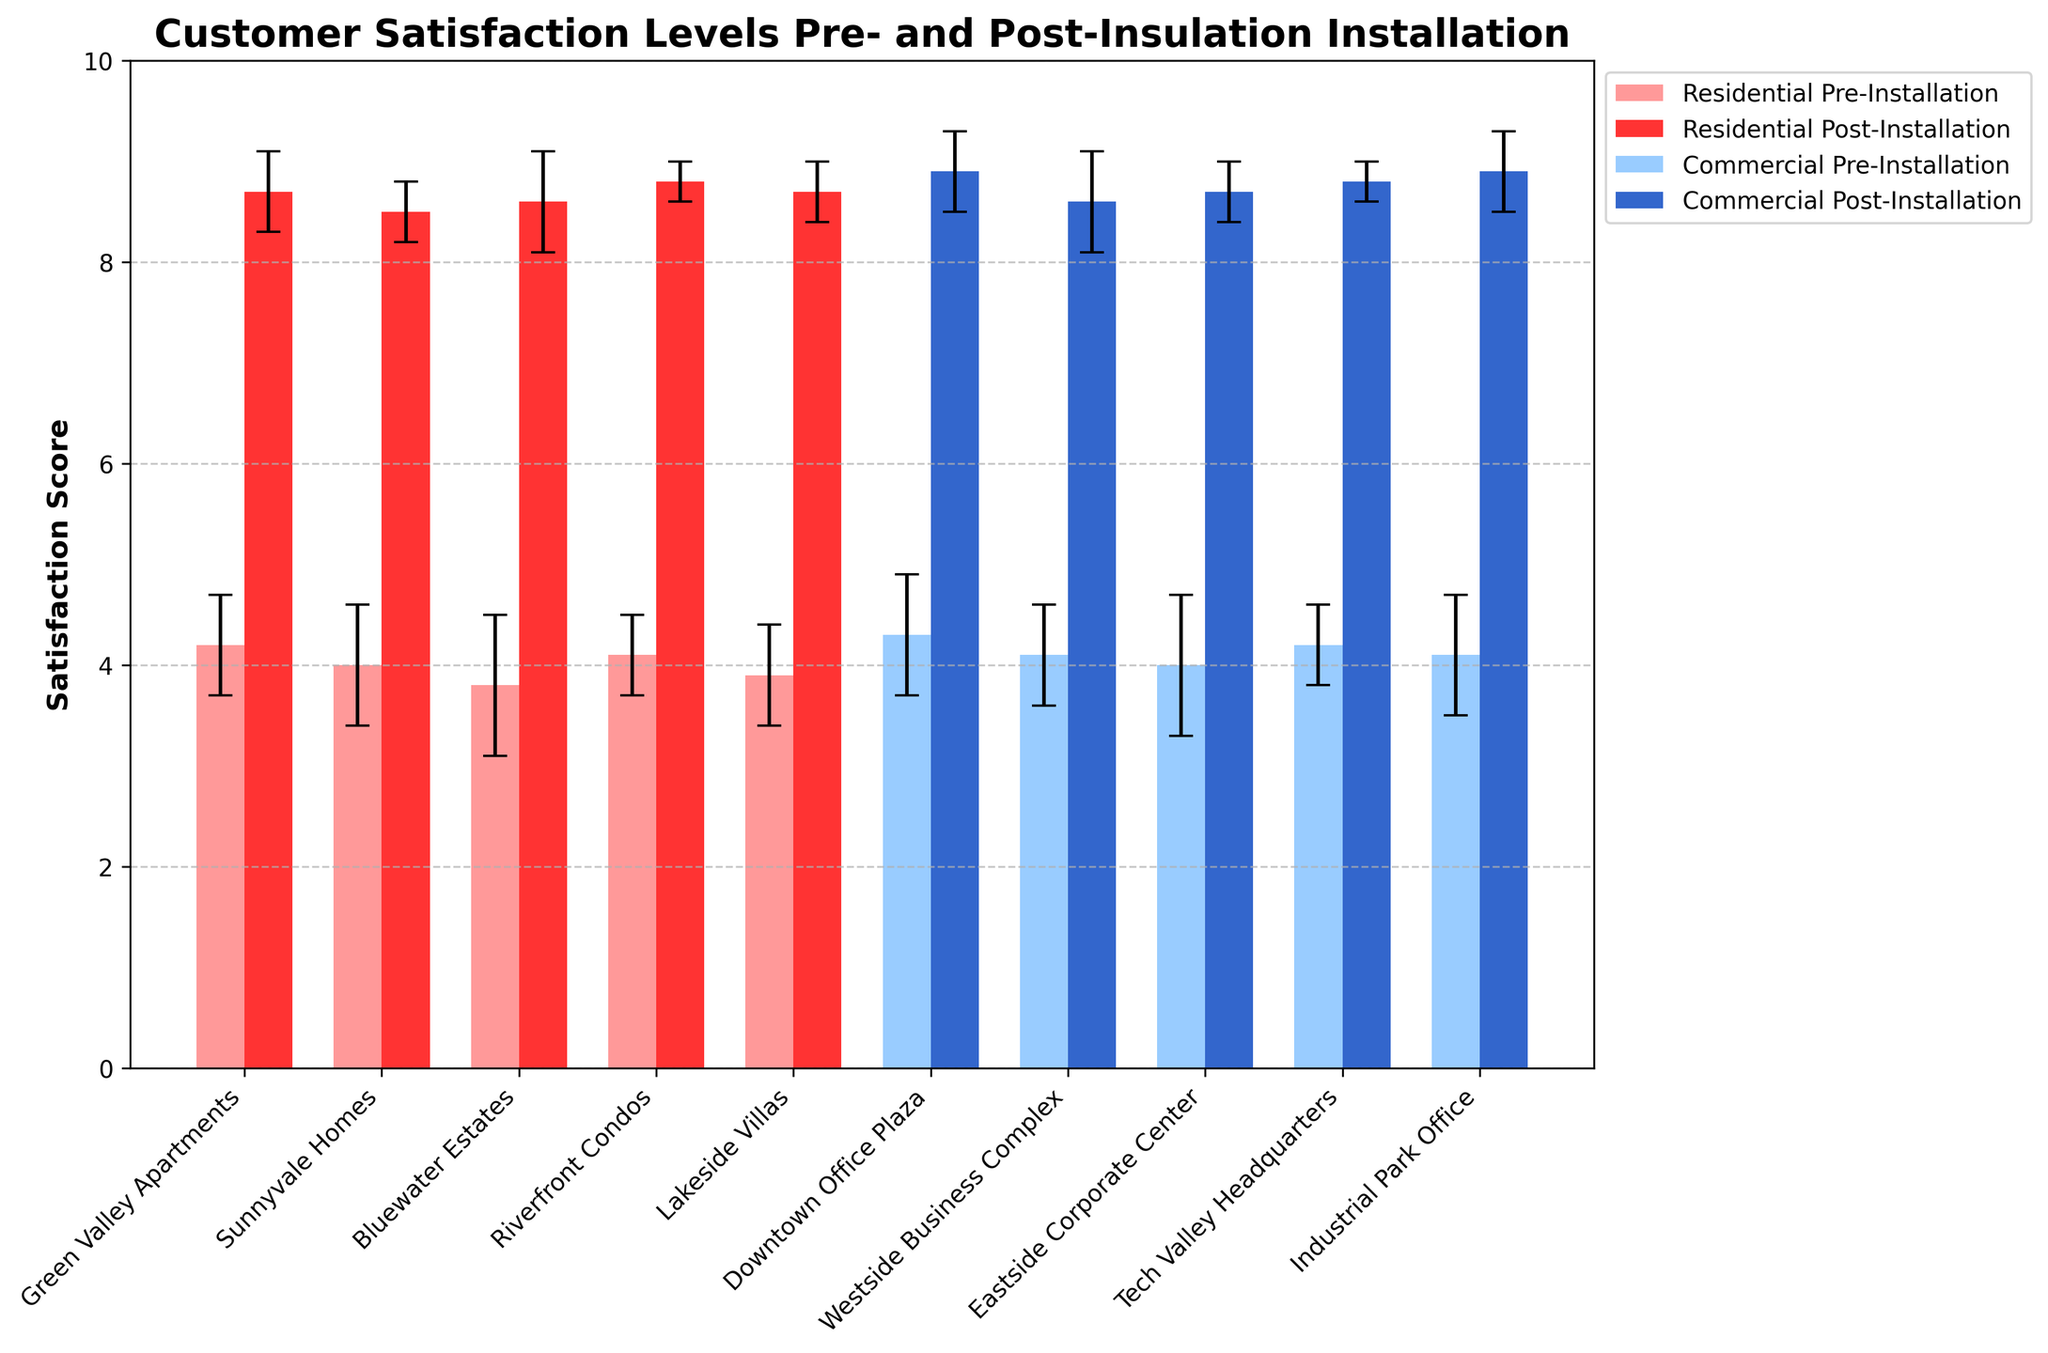What is the title of the plot? The title of the plot is usually located at the top of the figure. It provides a summary of what the figure represents. In this case, the title is "Customer Satisfaction Levels Pre- and Post-Insulation Installation."
Answer: Customer Satisfaction Levels Pre- and Post-Insulation Installation What is the color of the bars representing Residential projects post-installation? The bars for Residential projects post-installation can be identified by their color in the figure. According to the data, these bars are labeled with the color red.
Answer: Red How many Residential projects are shown in the figure? Count the number of different project names under the "Residential" category. In this case, they are Green Valley Apartments, Sunnyvale Homes, Bluewater Estates, Riverfront Condos, and Lakeside Villas.
Answer: 5 What is the average pre-installation satisfaction score for Residential projects? Sum up the pre-installation satisfaction means of all Residential projects and divide by the number of Residential projects. (4.2 + 4.0 + 3.8 + 4.1 + 3.9) / 5 = 20 / 5 = 4.0
Answer: 4.0 What is the range of satisfaction scores post-installation for Commercial projects? Identify the highest and lowest post-installation satisfaction scores from the Commercial projects and calculate the difference. The highest is 8.9, and the lowest is 8.6. So, the range is 8.9 - 8.6 = 0.3.
Answer: 0.3 Which project type shows a greater improvement in satisfaction scores post-installation? To determine this, calculate the average improvement for each type. For Residential: (8.7+8.5+8.6+8.8+8.7)/5 - (4.2+4.0+3.8+4.1+3.9)/5 = 8.66 - 4.0 = 4.66. For Commercial: (8.9+8.6+8.7+8.8+8.9)/5 - (4.3+4.1+4.0+4.2+4.1)/5 = 8.78 - 4.14 = 4.64. Residential shows a slightly greater improvement.
Answer: Residential What is the pre-installation satisfaction mean score for Green Valley Apartments and how does it compare to Tech Valley Headquarters? Look at the pre-installation satisfaction means for both projects. Green Valley Apartments has a score of 4.2, while Tech Valley Headquarters has 4.2 as well. They are the same.
Answer: Same Which project has the highest post-installation satisfaction score? Inspect the post-installation satisfaction means for all projects. The highest score is 8.9, which appears for Downtown Office Plaza and Industrial Park Office.
Answer: Downtown Office Plaza and Industrial Park Office What is the error bar length for the pre-installation satisfaction of Riverfront Condos? The error bar length represents the standard deviation, and for Riverfront Condos, this value is 0.4.
Answer: 0.4 